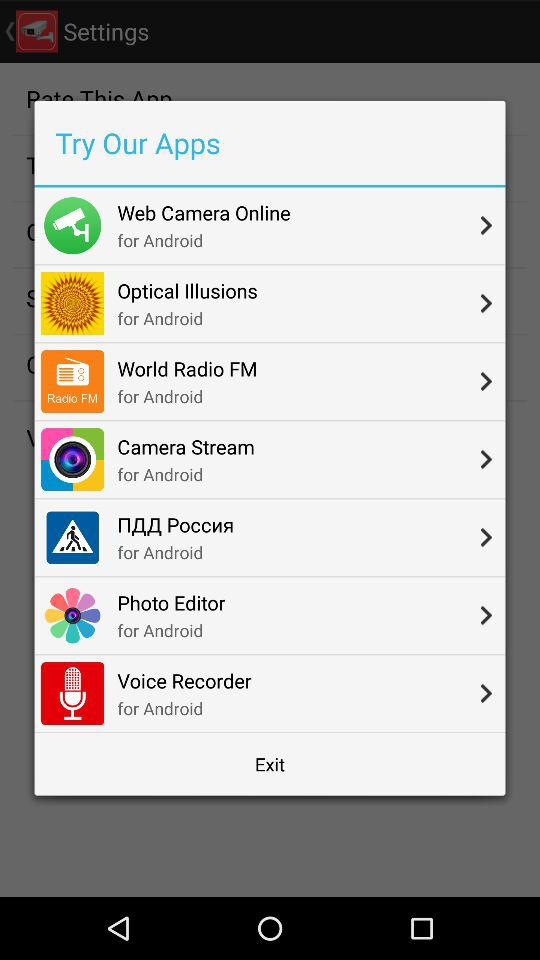How many of the apps are for Android?
Answer the question using a single word or phrase. 7 